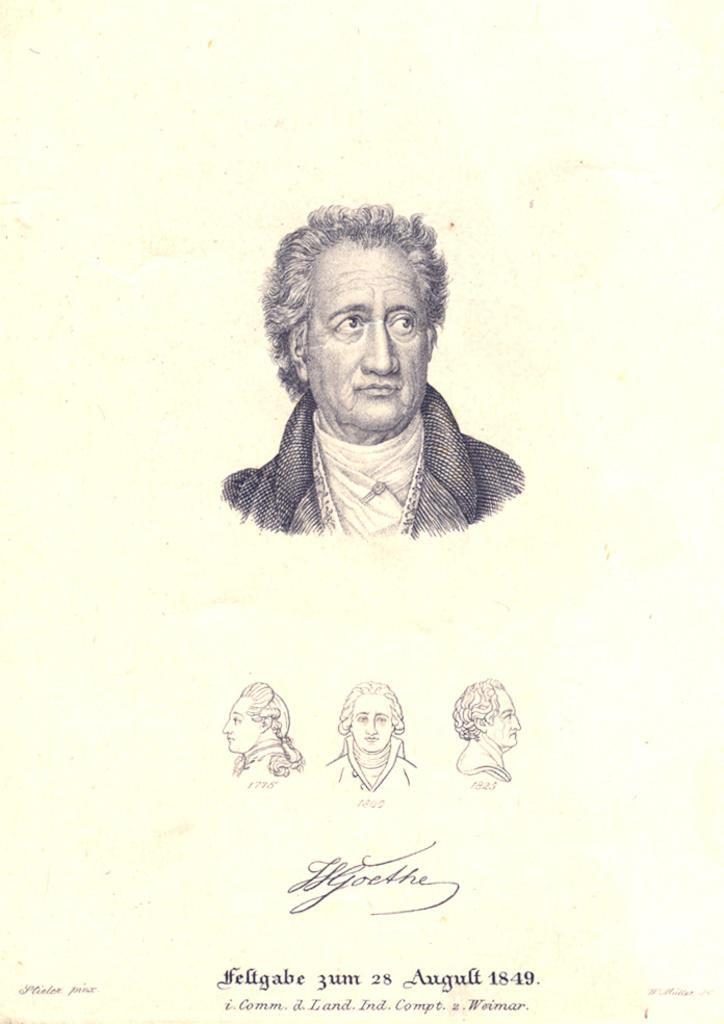What is the primary object in the image? There is a white paper in the image. What can be seen on the white paper? The paper contains images of four persons' faces. Is there a spy hiding behind the paper in the image? There is no indication of a spy or any hidden figure in the image; it only shows a white paper with images of four persons' faces. 